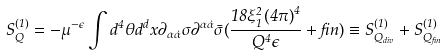Convert formula to latex. <formula><loc_0><loc_0><loc_500><loc_500>S _ { Q } ^ { ( 1 ) } = - \mu ^ { - \epsilon } \int d ^ { 4 } \theta d ^ { d } x \partial _ { \alpha \dot { \alpha } } \sigma \partial ^ { \alpha \dot { \alpha } } \bar { \sigma } ( \frac { 1 8 \xi _ { 1 } ^ { 2 } { ( 4 \pi ) } ^ { 4 } } { Q ^ { 4 } \epsilon } + f i n ) \equiv S _ { Q _ { d i v } } ^ { ( 1 ) } + S _ { Q _ { f i n } } ^ { ( 1 ) }</formula> 